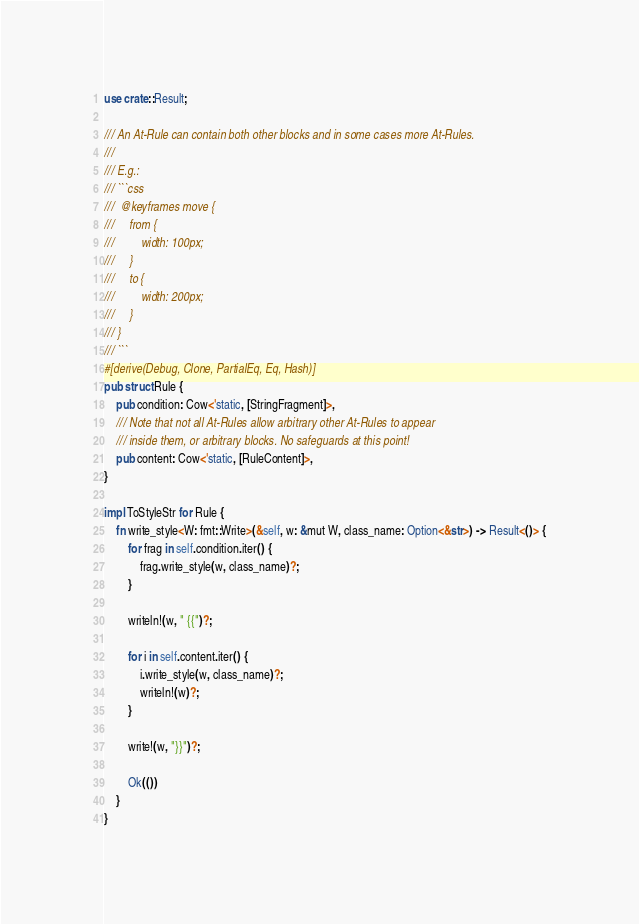Convert code to text. <code><loc_0><loc_0><loc_500><loc_500><_Rust_>use crate::Result;

/// An At-Rule can contain both other blocks and in some cases more At-Rules.
///
/// E.g.:
/// ```css
///  @keyframes move {
///     from {
///         width: 100px;
///     }
///     to {
///         width: 200px;
///     }
/// }
/// ```
#[derive(Debug, Clone, PartialEq, Eq, Hash)]
pub struct Rule {
    pub condition: Cow<'static, [StringFragment]>,
    /// Note that not all At-Rules allow arbitrary other At-Rules to appear
    /// inside them, or arbitrary blocks. No safeguards at this point!
    pub content: Cow<'static, [RuleContent]>,
}

impl ToStyleStr for Rule {
    fn write_style<W: fmt::Write>(&self, w: &mut W, class_name: Option<&str>) -> Result<()> {
        for frag in self.condition.iter() {
            frag.write_style(w, class_name)?;
        }

        writeln!(w, " {{")?;

        for i in self.content.iter() {
            i.write_style(w, class_name)?;
            writeln!(w)?;
        }

        write!(w, "}}")?;

        Ok(())
    }
}
</code> 